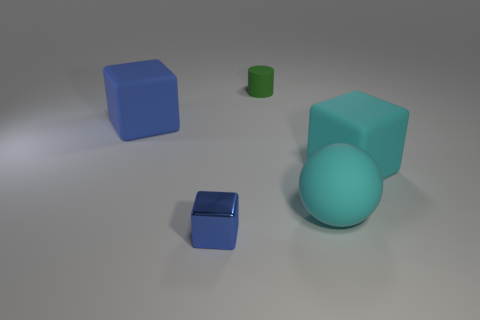Add 4 cyan rubber objects. How many objects exist? 9 Subtract all blocks. How many objects are left? 2 Add 3 large blue rubber cubes. How many large blue rubber cubes are left? 4 Add 2 large cyan objects. How many large cyan objects exist? 4 Subtract 1 green cylinders. How many objects are left? 4 Subtract all tiny things. Subtract all tiny blue metallic blocks. How many objects are left? 2 